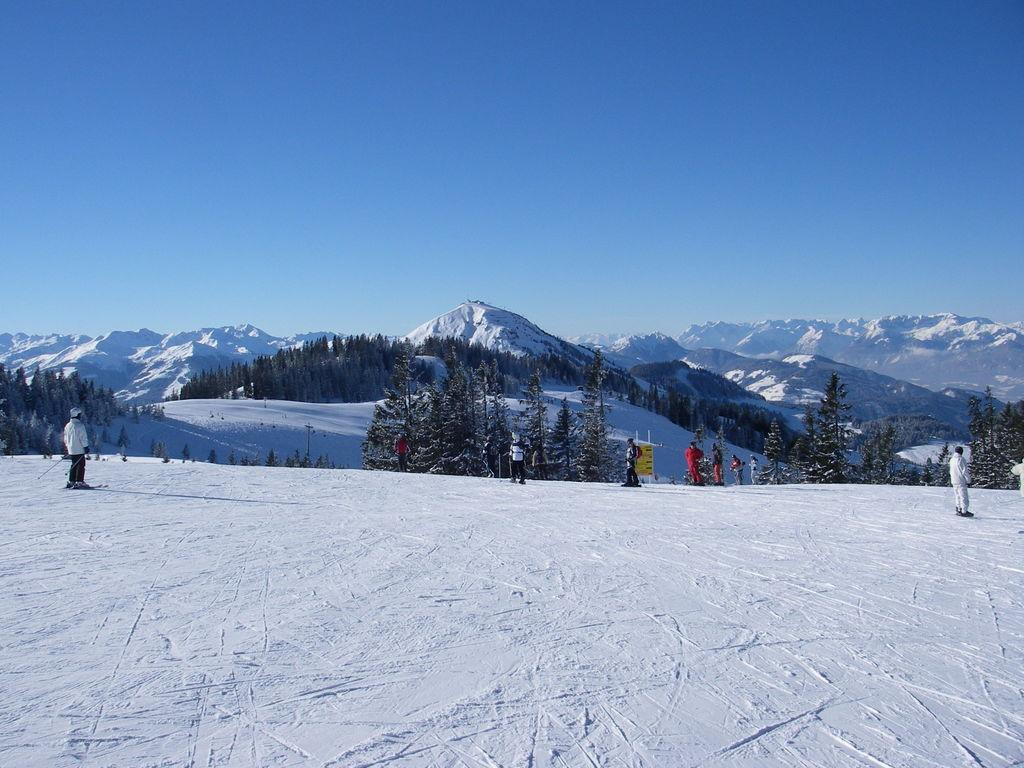What are the people in the image doing? The people in the image are standing and skating on the snow. What can be seen in the background of the image? There are hills covered with snow in the background. What type of vegetation is present in the image? There are trees in front of the hills. What is visible above the scene in the image? The sky is visible above the scene. What type of property is being sold by the doctor in the image? There is no doctor or property for sale present in the image. 